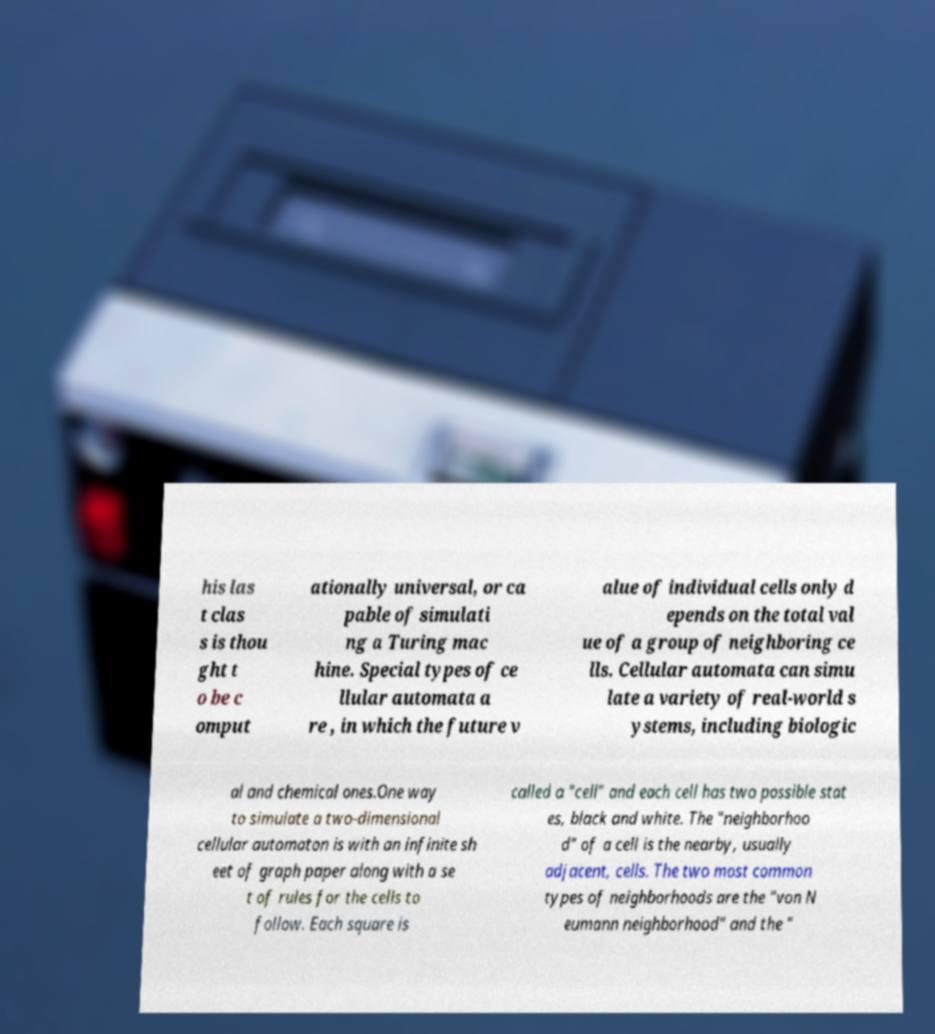Please identify and transcribe the text found in this image. his las t clas s is thou ght t o be c omput ationally universal, or ca pable of simulati ng a Turing mac hine. Special types of ce llular automata a re , in which the future v alue of individual cells only d epends on the total val ue of a group of neighboring ce lls. Cellular automata can simu late a variety of real-world s ystems, including biologic al and chemical ones.One way to simulate a two-dimensional cellular automaton is with an infinite sh eet of graph paper along with a se t of rules for the cells to follow. Each square is called a "cell" and each cell has two possible stat es, black and white. The "neighborhoo d" of a cell is the nearby, usually adjacent, cells. The two most common types of neighborhoods are the "von N eumann neighborhood" and the " 